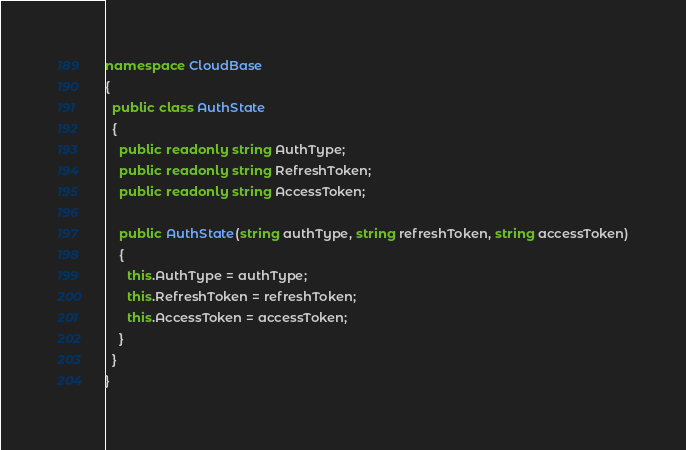<code> <loc_0><loc_0><loc_500><loc_500><_C#_>namespace CloudBase
{
  public class AuthState
  {
    public readonly string AuthType;
    public readonly string RefreshToken;
    public readonly string AccessToken;

    public AuthState(string authType, string refreshToken, string accessToken)
    {
      this.AuthType = authType;
      this.RefreshToken = refreshToken;
      this.AccessToken = accessToken;
    }
  }
}</code> 